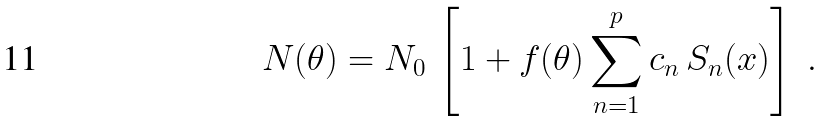<formula> <loc_0><loc_0><loc_500><loc_500>N ( \theta ) = N _ { 0 } \, \left [ 1 + f ( \theta ) \sum _ { n = 1 } ^ { p } c _ { n } \, S _ { n } ( x ) \right ] \ .</formula> 